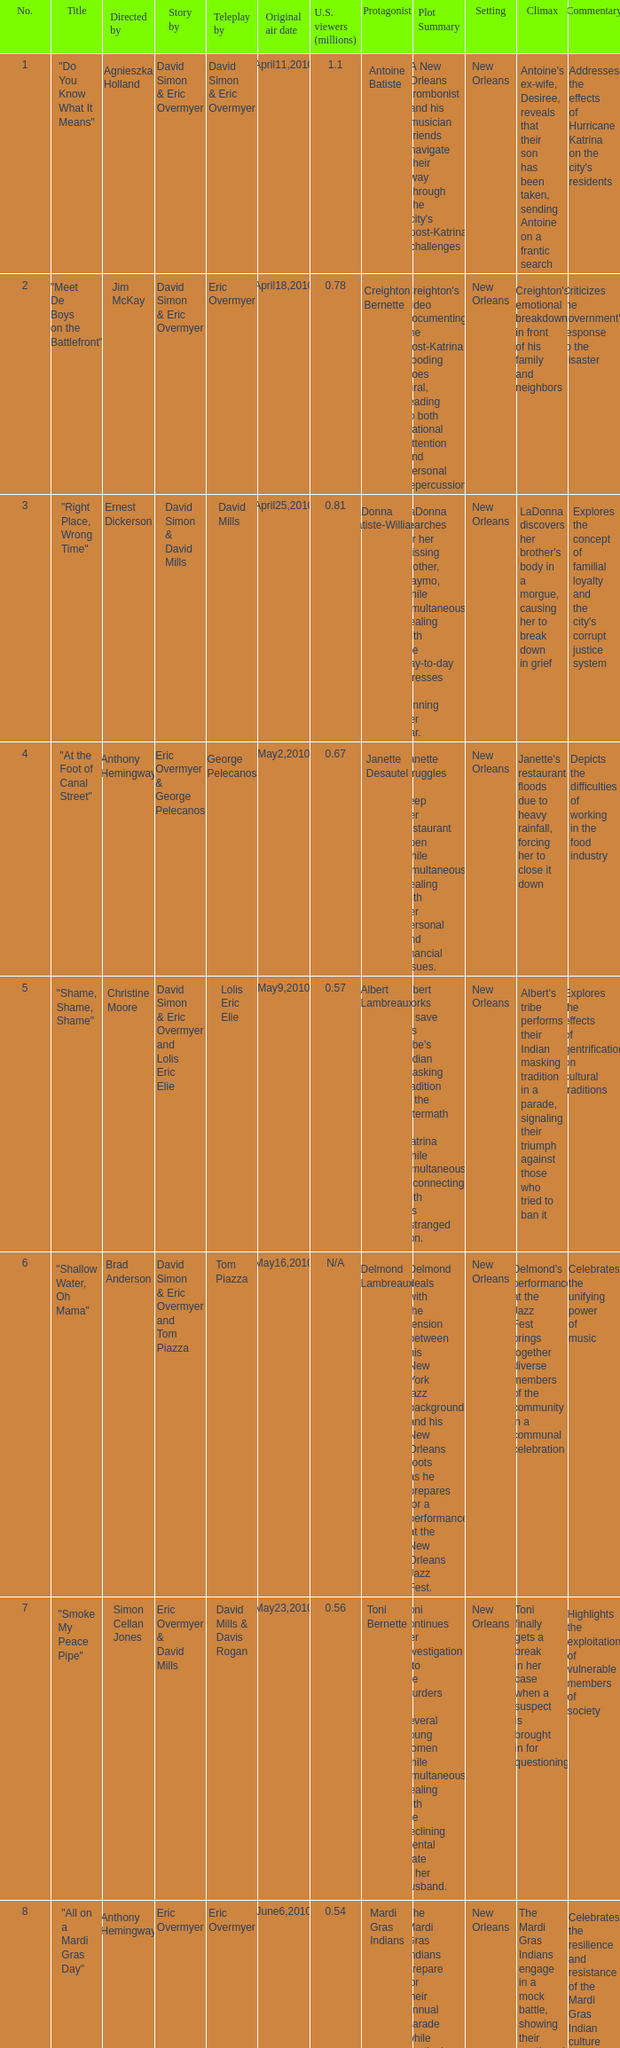Name the us viewers directed by christine moore 0.57. 